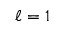<formula> <loc_0><loc_0><loc_500><loc_500>\ell = 1</formula> 